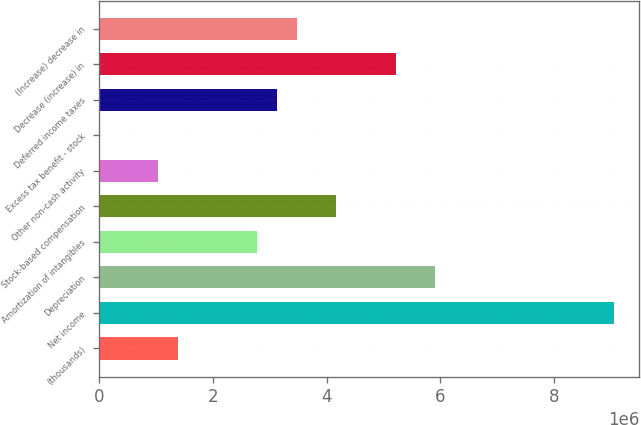<chart> <loc_0><loc_0><loc_500><loc_500><bar_chart><fcel>(thousands)<fcel>Net income<fcel>Depreciation<fcel>Amortization of intangibles<fcel>Stock-based compensation<fcel>Other non-cash activity<fcel>Excess tax benefit - stock<fcel>Deferred income taxes<fcel>Decrease (increase) in<fcel>(Increase) decrease in<nl><fcel>1.3914e+06<fcel>9.04236e+06<fcel>5.91242e+06<fcel>2.78248e+06<fcel>4.17357e+06<fcel>1.04363e+06<fcel>317<fcel>3.13025e+06<fcel>5.21688e+06<fcel>3.47802e+06<nl></chart> 